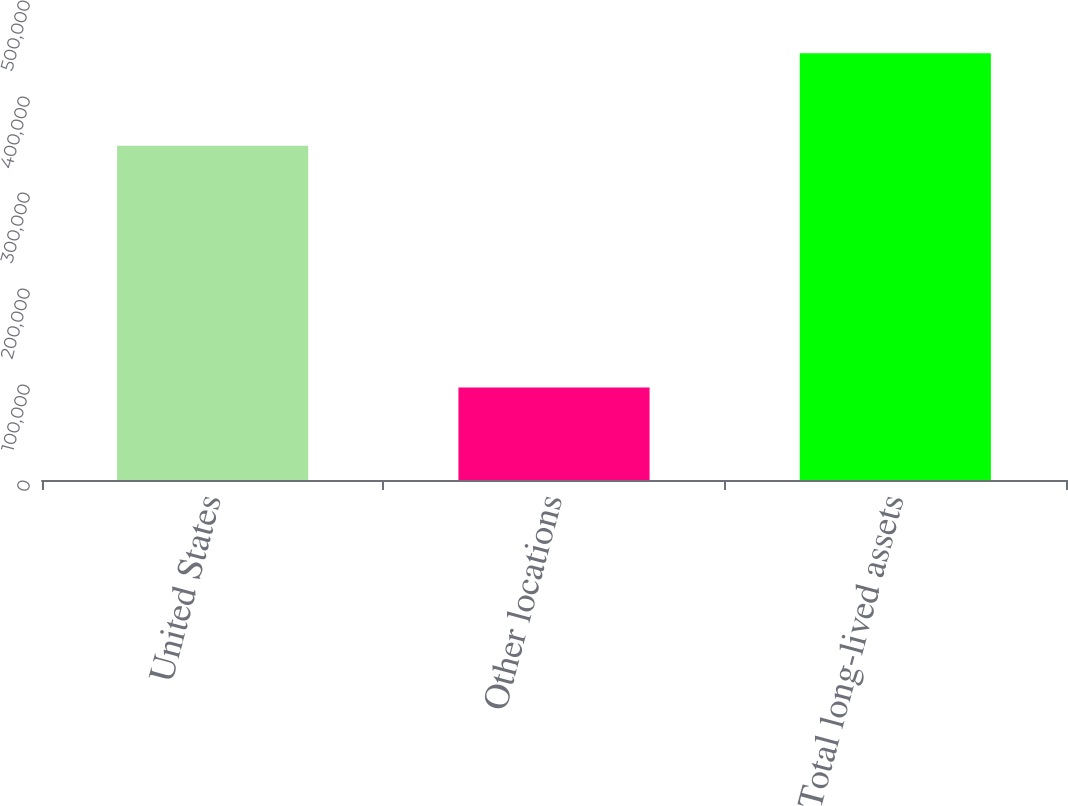<chart> <loc_0><loc_0><loc_500><loc_500><bar_chart><fcel>United States<fcel>Other locations<fcel>Total long-lived assets<nl><fcel>348299<fcel>96311<fcel>444610<nl></chart> 